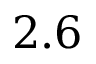Convert formula to latex. <formula><loc_0><loc_0><loc_500><loc_500>2 . 6</formula> 